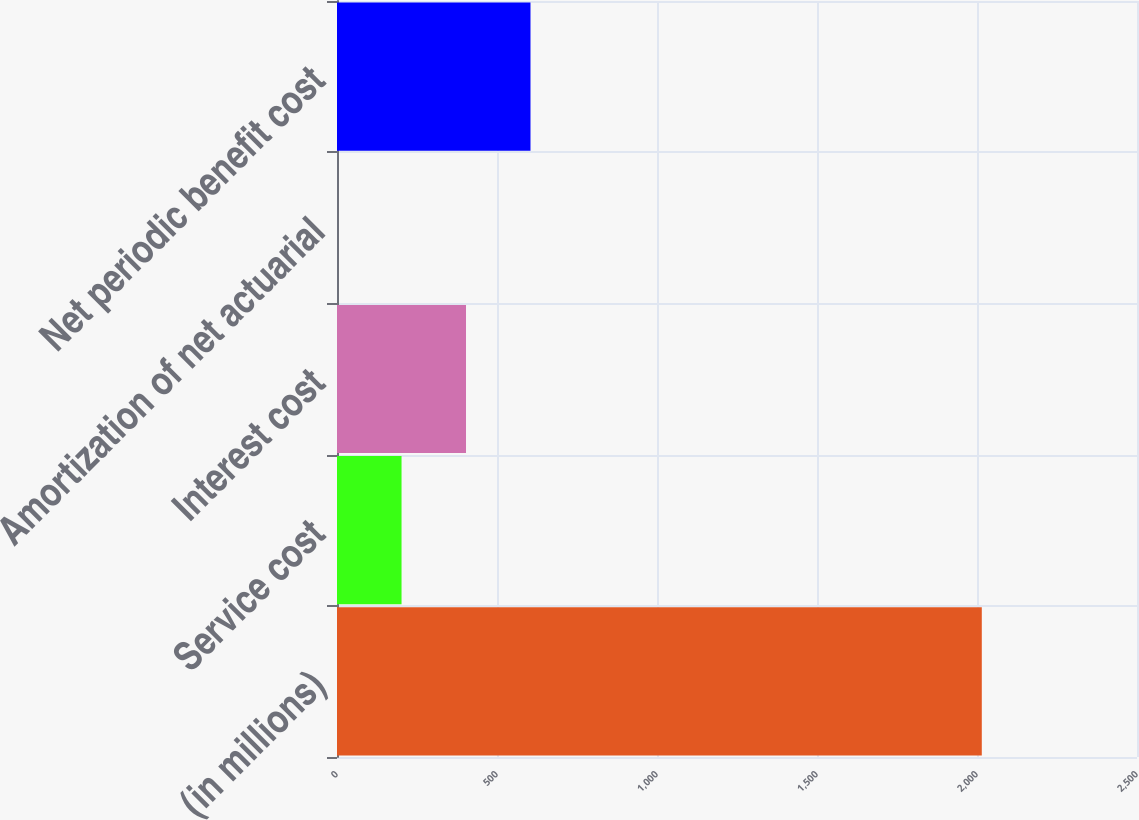<chart> <loc_0><loc_0><loc_500><loc_500><bar_chart><fcel>(in millions)<fcel>Service cost<fcel>Interest cost<fcel>Amortization of net actuarial<fcel>Net periodic benefit cost<nl><fcel>2015<fcel>201.68<fcel>403.16<fcel>0.2<fcel>604.64<nl></chart> 